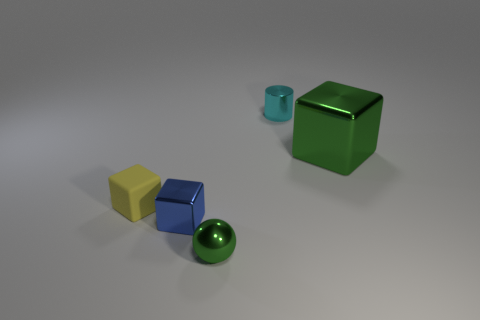There is a matte object that is the same size as the blue metal object; what color is it? The matte object that matches the size of the blue metal object is yellow. It appears to have a solid and uniform color without reflective properties, distinguishing it from the shinier metallic surfaces of the other objects. 